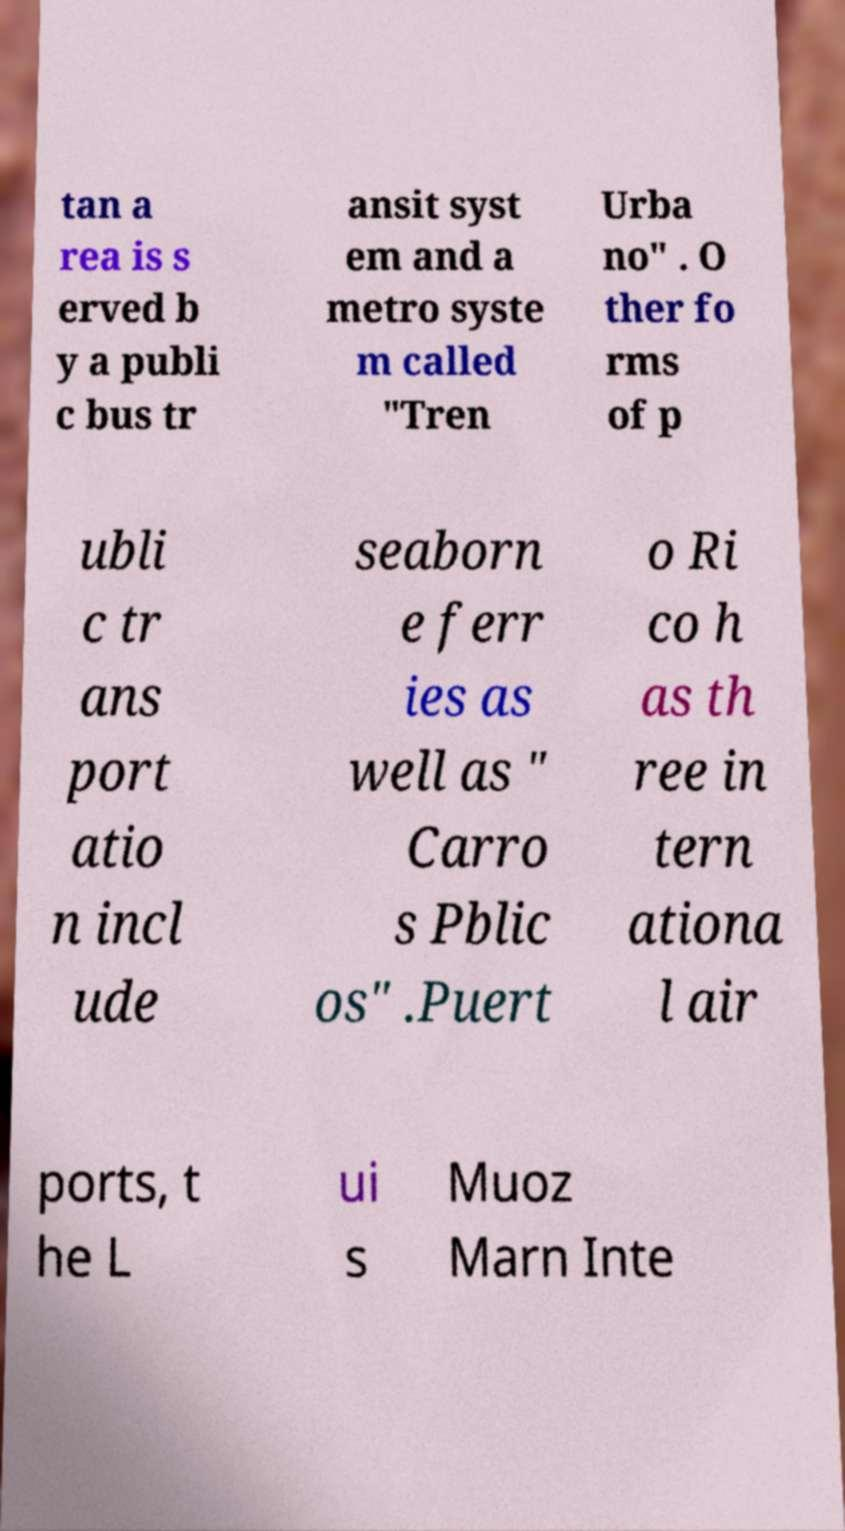I need the written content from this picture converted into text. Can you do that? tan a rea is s erved b y a publi c bus tr ansit syst em and a metro syste m called "Tren Urba no" . O ther fo rms of p ubli c tr ans port atio n incl ude seaborn e ferr ies as well as " Carro s Pblic os" .Puert o Ri co h as th ree in tern ationa l air ports, t he L ui s Muoz Marn Inte 